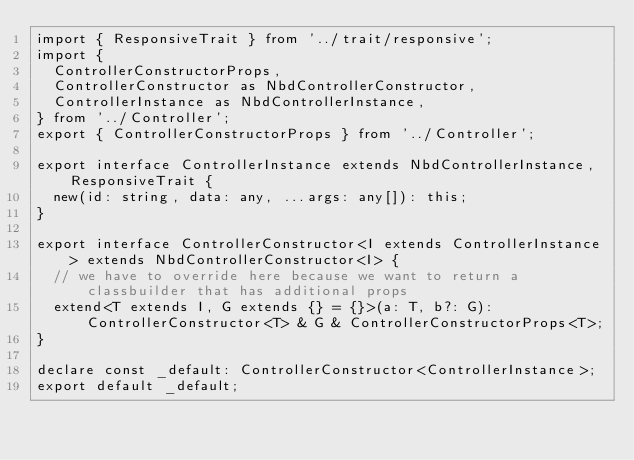Convert code to text. <code><loc_0><loc_0><loc_500><loc_500><_TypeScript_>import { ResponsiveTrait } from '../trait/responsive';
import {
  ControllerConstructorProps,
  ControllerConstructor as NbdControllerConstructor,
  ControllerInstance as NbdControllerInstance,
} from '../Controller';
export { ControllerConstructorProps } from '../Controller';

export interface ControllerInstance extends NbdControllerInstance, ResponsiveTrait {
  new(id: string, data: any, ...args: any[]): this;
}

export interface ControllerConstructor<I extends ControllerInstance> extends NbdControllerConstructor<I> {
  // we have to override here because we want to return a classbuilder that has additional props
  extend<T extends I, G extends {} = {}>(a: T, b?: G): ControllerConstructor<T> & G & ControllerConstructorProps<T>;
}

declare const _default: ControllerConstructor<ControllerInstance>;
export default _default;
</code> 